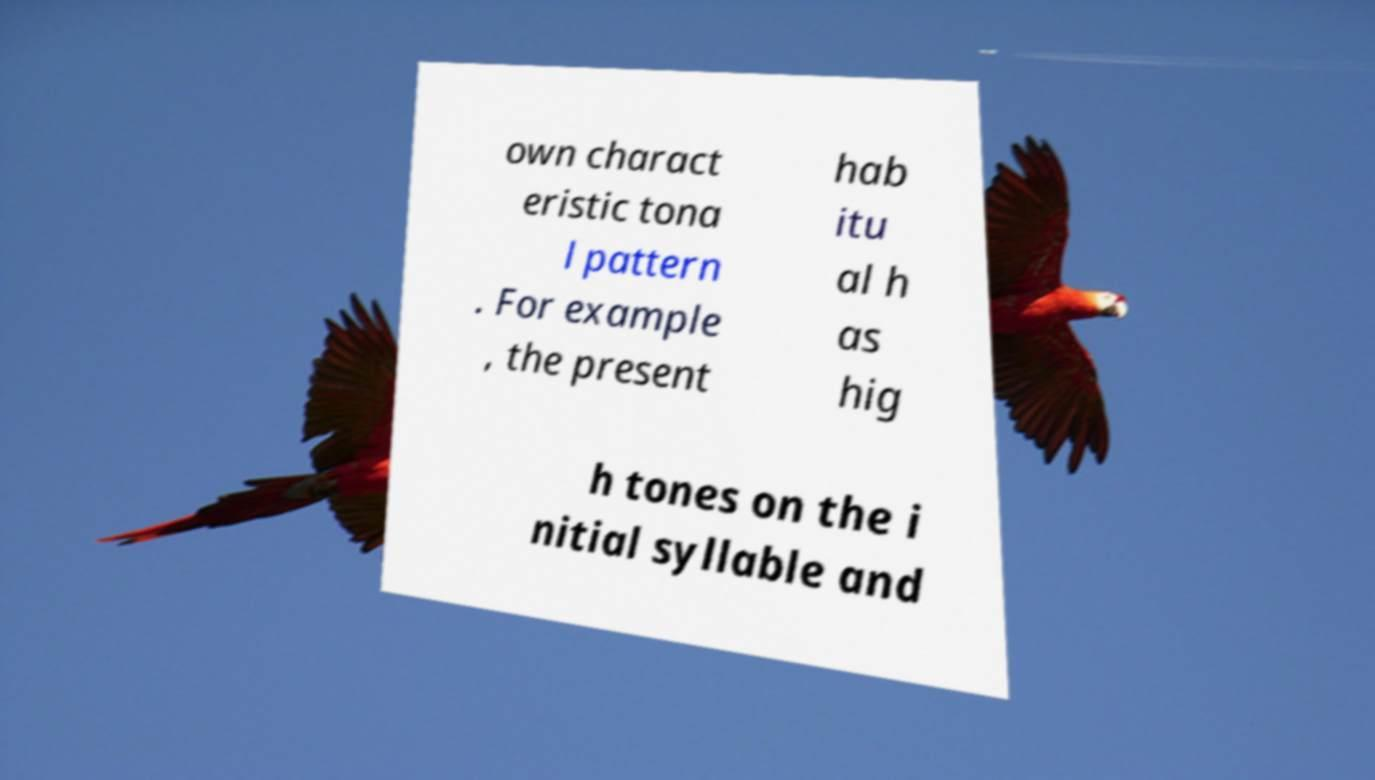Could you assist in decoding the text presented in this image and type it out clearly? own charact eristic tona l pattern . For example , the present hab itu al h as hig h tones on the i nitial syllable and 